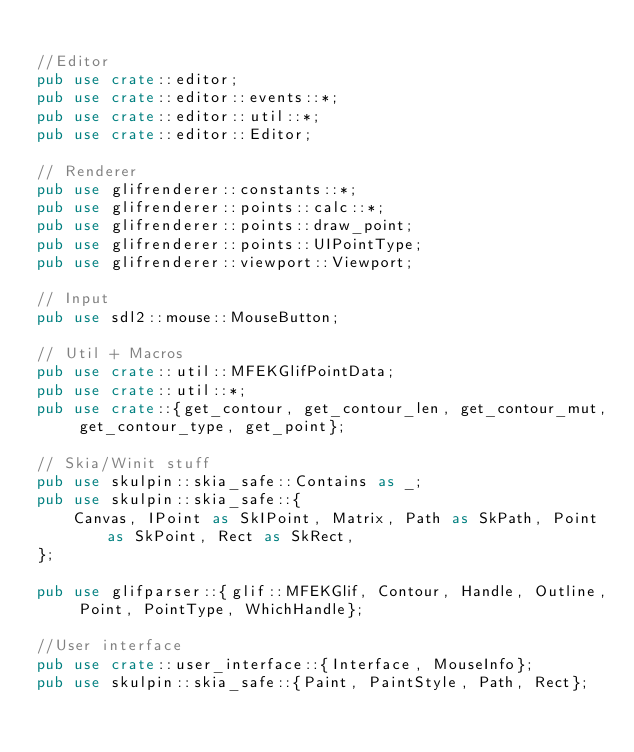<code> <loc_0><loc_0><loc_500><loc_500><_Rust_>
//Editor
pub use crate::editor;
pub use crate::editor::events::*;
pub use crate::editor::util::*;
pub use crate::editor::Editor;

// Renderer
pub use glifrenderer::constants::*;
pub use glifrenderer::points::calc::*;
pub use glifrenderer::points::draw_point;
pub use glifrenderer::points::UIPointType;
pub use glifrenderer::viewport::Viewport;

// Input
pub use sdl2::mouse::MouseButton;

// Util + Macros
pub use crate::util::MFEKGlifPointData;
pub use crate::util::*;
pub use crate::{get_contour, get_contour_len, get_contour_mut, get_contour_type, get_point};

// Skia/Winit stuff
pub use skulpin::skia_safe::Contains as _;
pub use skulpin::skia_safe::{
    Canvas, IPoint as SkIPoint, Matrix, Path as SkPath, Point as SkPoint, Rect as SkRect,
};

pub use glifparser::{glif::MFEKGlif, Contour, Handle, Outline, Point, PointType, WhichHandle};

//User interface
pub use crate::user_interface::{Interface, MouseInfo};
pub use skulpin::skia_safe::{Paint, PaintStyle, Path, Rect};
</code> 